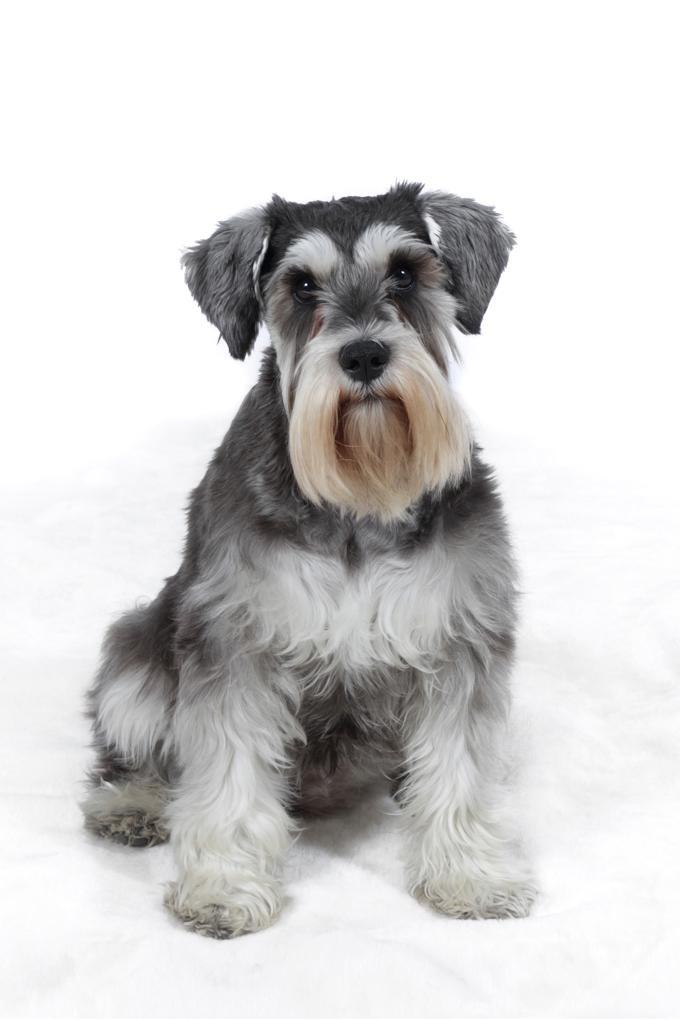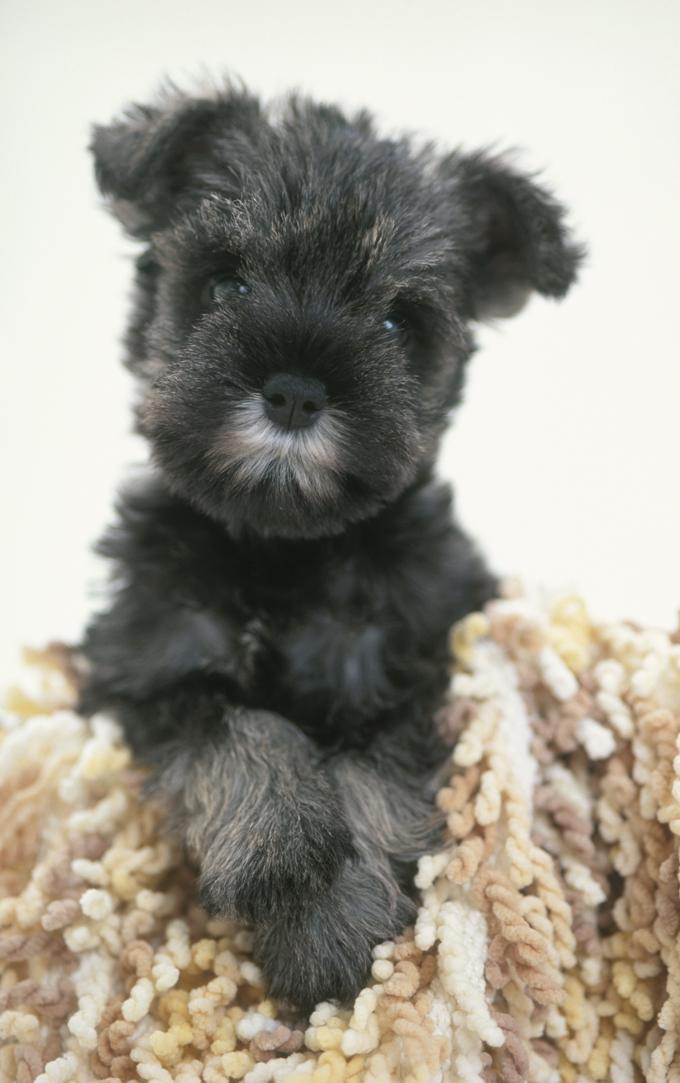The first image is the image on the left, the second image is the image on the right. Analyze the images presented: Is the assertion "At least one image is a solo black dog." valid? Answer yes or no. Yes. 